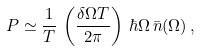<formula> <loc_0><loc_0><loc_500><loc_500>P \simeq \frac { 1 } { T } \, \left ( \frac { \delta \Omega T } { 2 \pi } \right ) \, \hbar { \Omega } \, \bar { n } ( \Omega ) \, ,</formula> 